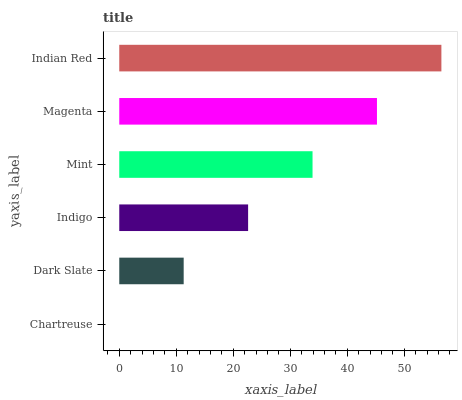Is Chartreuse the minimum?
Answer yes or no. Yes. Is Indian Red the maximum?
Answer yes or no. Yes. Is Dark Slate the minimum?
Answer yes or no. No. Is Dark Slate the maximum?
Answer yes or no. No. Is Dark Slate greater than Chartreuse?
Answer yes or no. Yes. Is Chartreuse less than Dark Slate?
Answer yes or no. Yes. Is Chartreuse greater than Dark Slate?
Answer yes or no. No. Is Dark Slate less than Chartreuse?
Answer yes or no. No. Is Mint the high median?
Answer yes or no. Yes. Is Indigo the low median?
Answer yes or no. Yes. Is Chartreuse the high median?
Answer yes or no. No. Is Indian Red the low median?
Answer yes or no. No. 